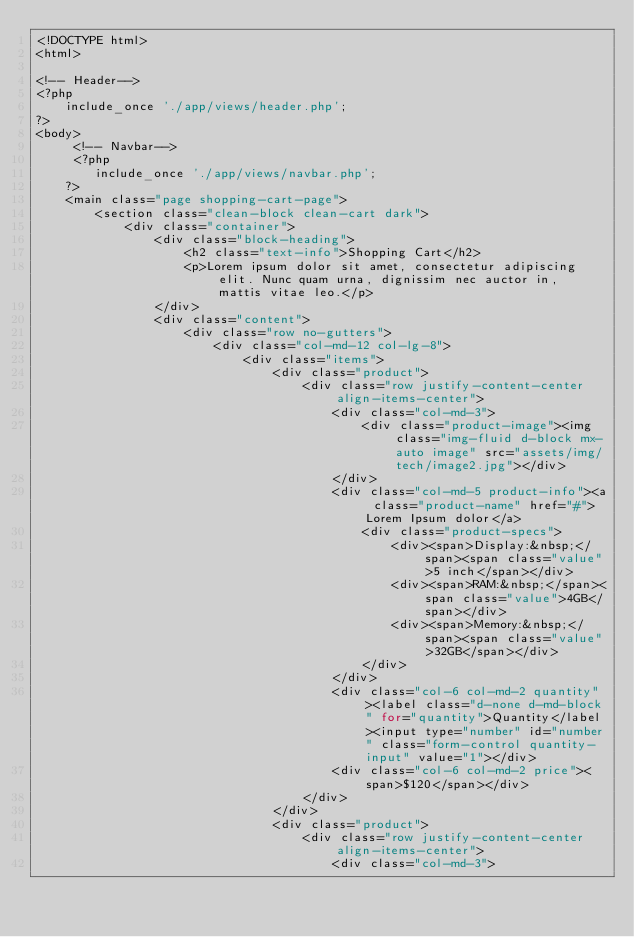<code> <loc_0><loc_0><loc_500><loc_500><_PHP_><!DOCTYPE html>
<html>

<!-- Header-->
<?php
    include_once './app/views/header.php';
?>
<body>
     <!-- Navbar-->
     <?php 
        include_once './app/views/navbar.php';
    ?>
    <main class="page shopping-cart-page">
        <section class="clean-block clean-cart dark">
            <div class="container">
                <div class="block-heading">
                    <h2 class="text-info">Shopping Cart</h2>
                    <p>Lorem ipsum dolor sit amet, consectetur adipiscing elit. Nunc quam urna, dignissim nec auctor in, mattis vitae leo.</p>
                </div>
                <div class="content">
                    <div class="row no-gutters">
                        <div class="col-md-12 col-lg-8">
                            <div class="items">
                                <div class="product">
                                    <div class="row justify-content-center align-items-center">
                                        <div class="col-md-3">
                                            <div class="product-image"><img class="img-fluid d-block mx-auto image" src="assets/img/tech/image2.jpg"></div>
                                        </div>
                                        <div class="col-md-5 product-info"><a class="product-name" href="#">Lorem Ipsum dolor</a>
                                            <div class="product-specs">
                                                <div><span>Display:&nbsp;</span><span class="value">5 inch</span></div>
                                                <div><span>RAM:&nbsp;</span><span class="value">4GB</span></div>
                                                <div><span>Memory:&nbsp;</span><span class="value">32GB</span></div>
                                            </div>
                                        </div>
                                        <div class="col-6 col-md-2 quantity"><label class="d-none d-md-block" for="quantity">Quantity</label><input type="number" id="number" class="form-control quantity-input" value="1"></div>
                                        <div class="col-6 col-md-2 price"><span>$120</span></div>
                                    </div>
                                </div>
                                <div class="product">
                                    <div class="row justify-content-center align-items-center">
                                        <div class="col-md-3"></code> 